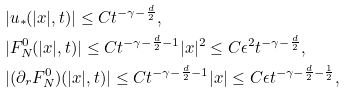<formula> <loc_0><loc_0><loc_500><loc_500>& | u _ { * } ( | x | , t ) | \leq C t ^ { - \gamma - \frac { d } { 2 } } , \\ & | F _ { N } ^ { 0 } ( | x | , t ) | \leq C t ^ { - \gamma - \frac { d } { 2 } - 1 } | x | ^ { 2 } \leq C \epsilon ^ { 2 } t ^ { - \gamma - \frac { d } { 2 } } , \\ & | ( \partial _ { r } F _ { N } ^ { 0 } ) ( | x | , t ) | \leq C t ^ { - \gamma - \frac { d } { 2 } - 1 } | x | \leq C \epsilon t ^ { - \gamma - \frac { d } { 2 } - \frac { 1 } { 2 } } ,</formula> 